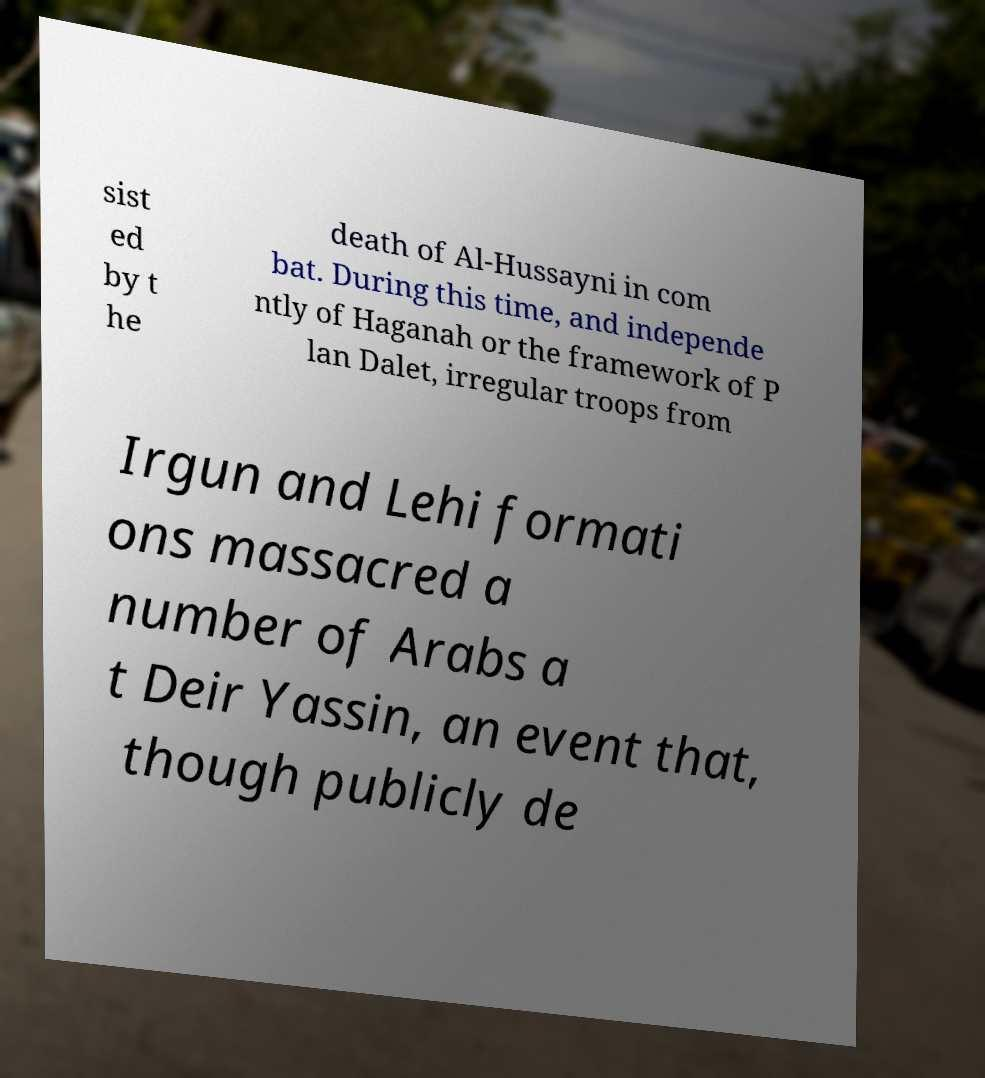Can you read and provide the text displayed in the image?This photo seems to have some interesting text. Can you extract and type it out for me? sist ed by t he death of Al-Hussayni in com bat. During this time, and independe ntly of Haganah or the framework of P lan Dalet, irregular troops from Irgun and Lehi formati ons massacred a number of Arabs a t Deir Yassin, an event that, though publicly de 